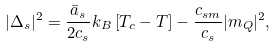<formula> <loc_0><loc_0><loc_500><loc_500>| \Delta _ { s } | ^ { 2 } = \frac { \bar { a } _ { s } } { 2 c _ { s } } k _ { B } \left [ T _ { c } - T \right ] - \frac { c _ { s m } } { c _ { s } } | m _ { Q } | ^ { 2 } ,</formula> 